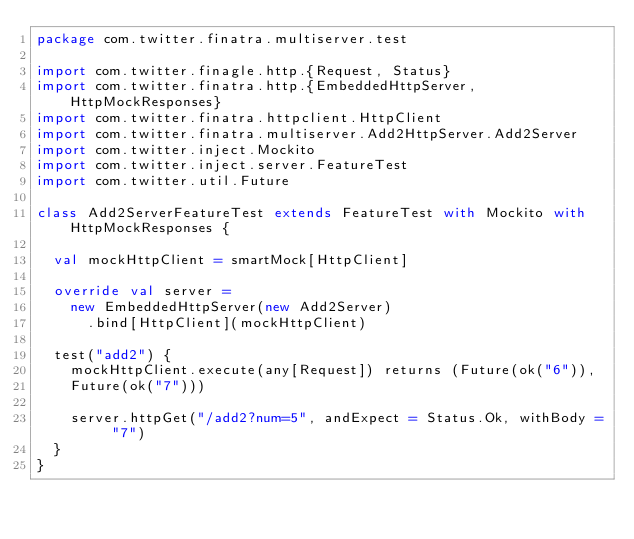Convert code to text. <code><loc_0><loc_0><loc_500><loc_500><_Scala_>package com.twitter.finatra.multiserver.test

import com.twitter.finagle.http.{Request, Status}
import com.twitter.finatra.http.{EmbeddedHttpServer, HttpMockResponses}
import com.twitter.finatra.httpclient.HttpClient
import com.twitter.finatra.multiserver.Add2HttpServer.Add2Server
import com.twitter.inject.Mockito
import com.twitter.inject.server.FeatureTest
import com.twitter.util.Future

class Add2ServerFeatureTest extends FeatureTest with Mockito with HttpMockResponses {

  val mockHttpClient = smartMock[HttpClient]

  override val server =
    new EmbeddedHttpServer(new Add2Server)
      .bind[HttpClient](mockHttpClient)

  test("add2") {
    mockHttpClient.execute(any[Request]) returns (Future(ok("6")),
    Future(ok("7")))

    server.httpGet("/add2?num=5", andExpect = Status.Ok, withBody = "7")
  }
}
</code> 